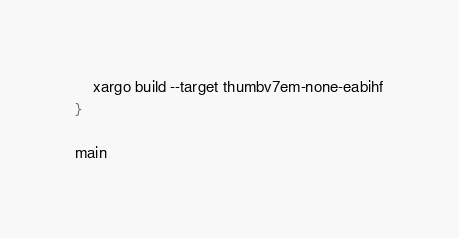Convert code to text. <code><loc_0><loc_0><loc_500><loc_500><_Bash_>
    xargo build --target thumbv7em-none-eabihf
}

main
</code> 